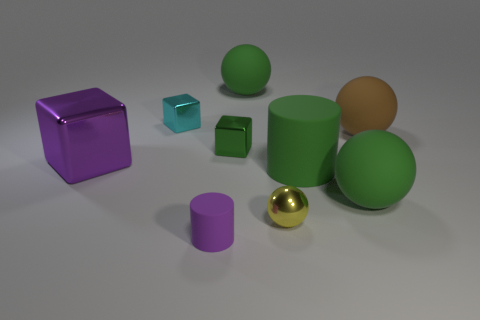There is a rubber cylinder right of the metal thing that is in front of the large metal block; what number of tiny yellow metal objects are right of it?
Your answer should be very brief. 0. Is there anything else that is the same color as the large rubber cylinder?
Ensure brevity in your answer.  Yes. There is a rubber thing behind the tiny cyan metal thing; is it the same color as the metal thing in front of the purple metallic object?
Your answer should be compact. No. Is the number of small metallic objects that are left of the purple rubber cylinder greater than the number of big blocks that are on the right side of the tiny green metallic cube?
Provide a short and direct response. Yes. What is the material of the brown sphere?
Give a very brief answer. Rubber. The large purple shiny object left of the metallic object to the right of the big rubber ball that is behind the large brown rubber ball is what shape?
Your response must be concise. Cube. How many other things are the same material as the green cylinder?
Your answer should be compact. 4. Is the material of the small green block that is behind the large cylinder the same as the cylinder that is behind the metal sphere?
Give a very brief answer. No. What number of tiny things are both in front of the brown ball and behind the small purple object?
Offer a very short reply. 2. Are there any other small metallic objects that have the same shape as the brown object?
Provide a short and direct response. Yes. 